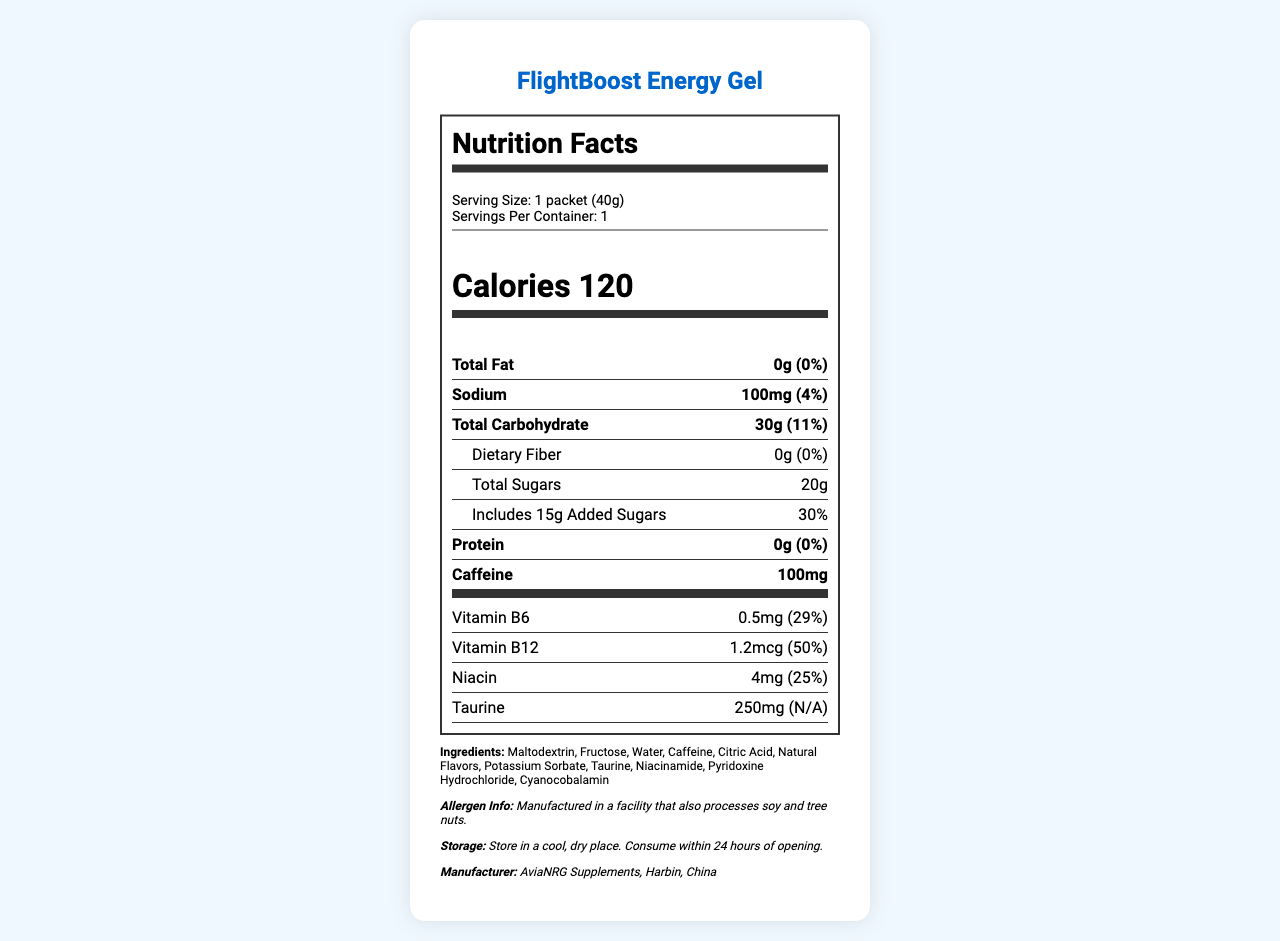what is the serving size of FlightBoost Energy Gel? The serving size is explicitly mentioned at the top of the nutrition label as "Serving Size: 1 packet (40g)".
Answer: 1 packet (40g) how many calories are in one serving of FlightBoost Energy Gel? The nutrition label clearly lists the calories per serving at the top in a bold font: "Calories 120".
Answer: 120 what is the amount of caffeine in one serving? The amount of caffeine per serving is specified under the nutrient information as "Caffeine: 100mg".
Answer: 100mg how much sodium does one serving contain? This information is found in the nutrient data section: "Sodium: 100mg".
Answer: 100mg what percentage of the daily value of Vitamin B6 is present? The daily value percentage for Vitamin B6 is listed under the "Vitamins and Minerals" section as "Vitamin B6: 29%".
Answer: 29% how much added sugars are there in one serving? This detail is found in the sub-nutrient section under "Total Carbohydrate" listed as "Includes 15g Added Sugars".
Answer: 15g how much Niacin is present in one serving? The amount of Niacin is listed under the "Vitamins and Minerals" section as "Niacin: 4mg".
Answer: 4mg which of the following is NOT an ingredient in FlightBoost Energy Gel? A. Fructose B. Water C. Cocoa D. Citric Acid The ingredients section lists various components including Fructose, Water, and Citric Acid, but Cocoa is not mentioned.
Answer: C. Cocoa how many total carbohydrates are in a serving? A. 20g B. 25g C. 30g D. 35g The total carbohydrate amount is clearly listed under the nutrient information as "Total Carbohydrate: 30g".
Answer: C. 30g is there any dietary fiber in this energy gel? The document mentions under the sub-nutrient section for "Total Carbohydrate" that Dietary Fiber is "0g".
Answer: No is FlightBoost Energy Gel recommended for use outside of supervised flight training sessions? The usage instructions explicitly state: "Not recommended for use outside of supervised flight training sessions."
Answer: No summarize the main purpose and key information of the FlightBoost Energy Gel document. The document aims to provide a complete nutritional breakdown and usage guidance for FlightBoost Energy Gel, highlighting its suitability for flight training by offering quick energy via carbohydrates and caffeine, along with certain vitamins.
Answer: FlightBoost Energy Gel is a specially formulated product for aviation students at Harbin Flight Academy. It provides energy and enhanced alertness during flight training sessions. The product offers 120 calories per serving with 30g of carbohydrates and 100mg of caffeine to improve focus. It contains various vitamins and taurine but no fat, fiber, or protein. The document also provides ingredient details, allergen information, storage instructions, and usage recommendations. can the exact manufacturing date of the FlightBoost Energy Gel be determined from the document? The document does not provide any information related to the manufacturing date; it only mentions the manufacturer and storage instructions.
Answer: Cannot be determined 